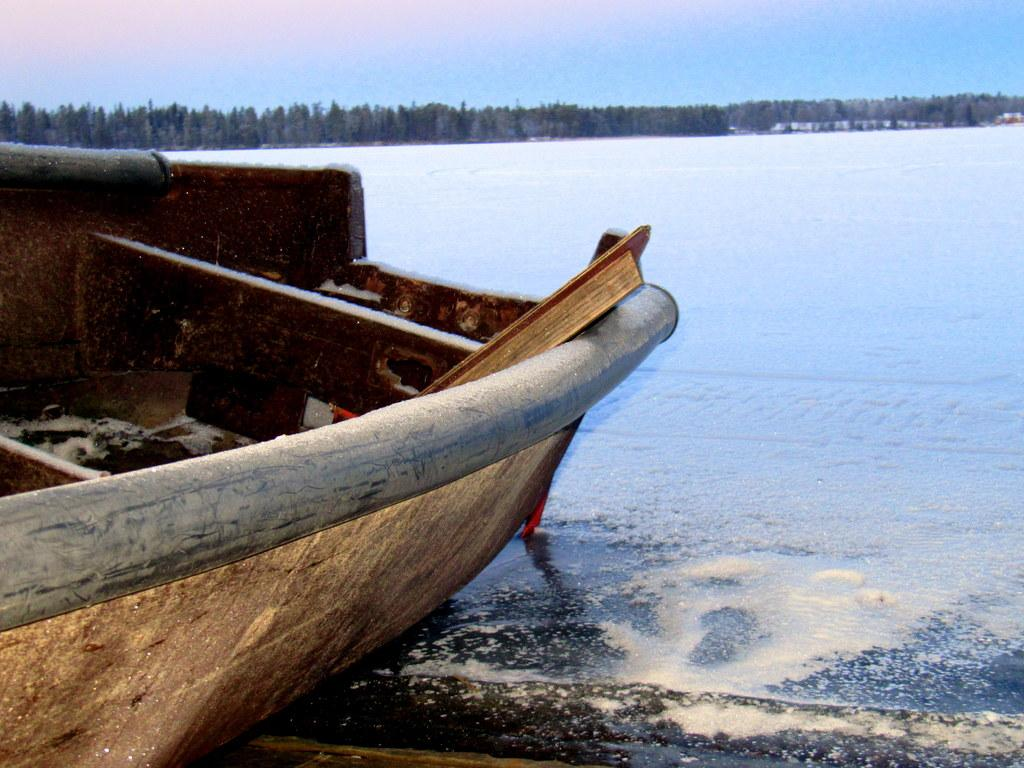What is the main subject of the image? The main subject of the image is a boat. Where is the boat located? The boat is on the water. What can be seen in the background of the image? There are many trees and the sky visible in the background of the image. How many nails can be seen holding the boat together in the image? There are no nails visible in the image; the boat's construction is not shown. 